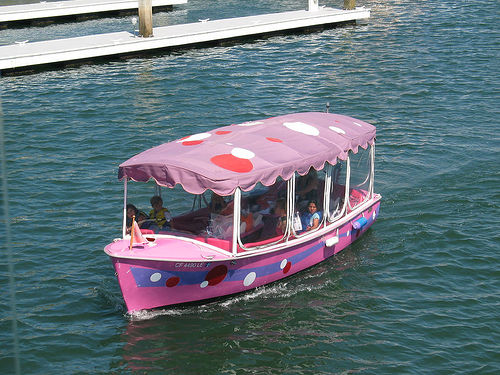Describe the mood of the people on the boat. The passengers on the boat appear to be in good spirits, enjoying their time on this delightful and amusing ride. While individual facial expressions are indistinguishable, the overall body language, with passengers looking out over the water and engaging with each other, conveys a relaxed and cheerful atmosphere. 